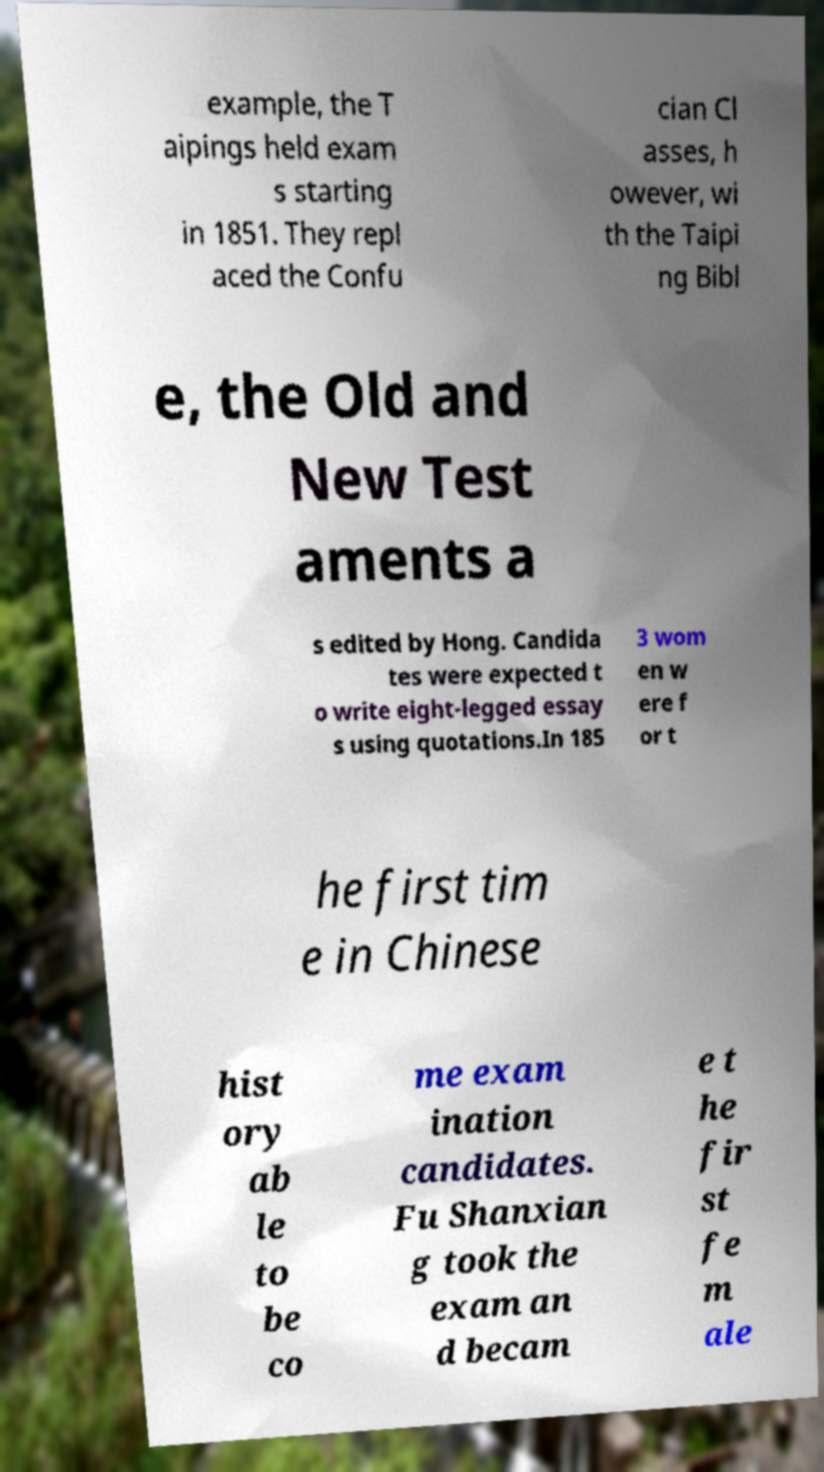Could you extract and type out the text from this image? example, the T aipings held exam s starting in 1851. They repl aced the Confu cian Cl asses, h owever, wi th the Taipi ng Bibl e, the Old and New Test aments a s edited by Hong. Candida tes were expected t o write eight-legged essay s using quotations.In 185 3 wom en w ere f or t he first tim e in Chinese hist ory ab le to be co me exam ination candidates. Fu Shanxian g took the exam an d becam e t he fir st fe m ale 